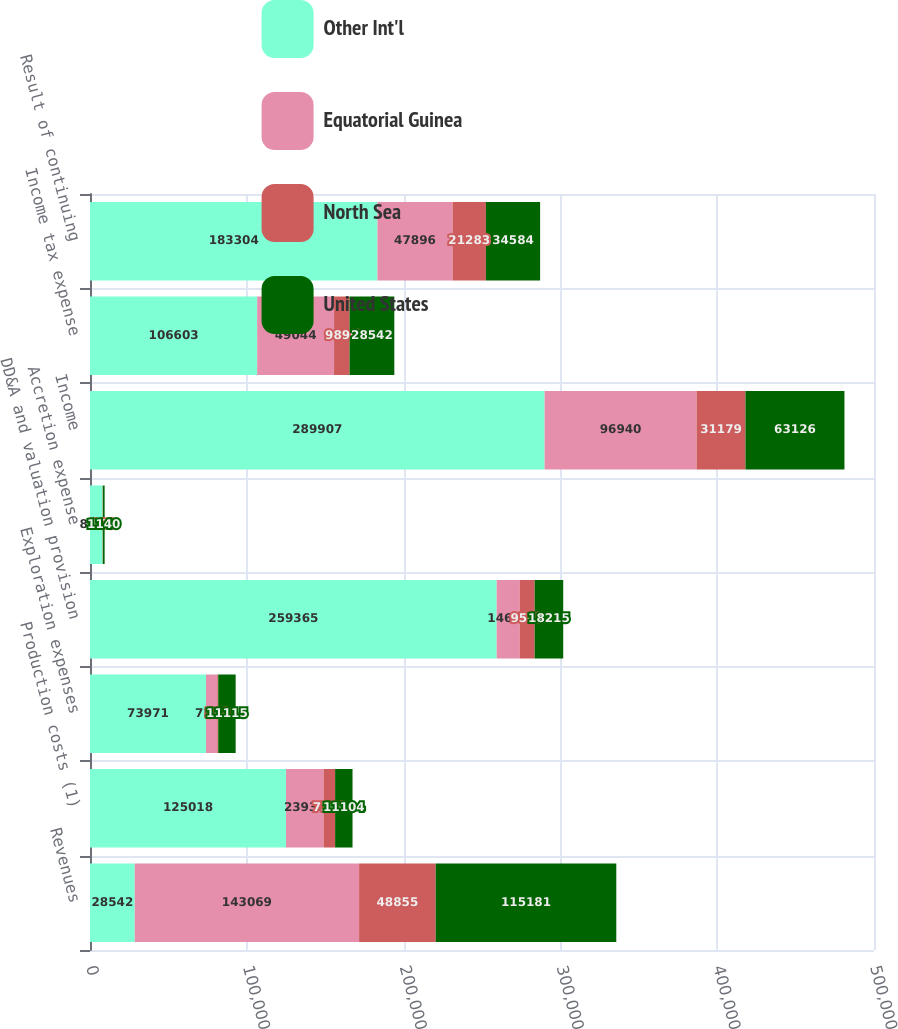Convert chart. <chart><loc_0><loc_0><loc_500><loc_500><stacked_bar_chart><ecel><fcel>Revenues<fcel>Production costs (1)<fcel>Exploration expenses<fcel>DD&A and valuation provision<fcel>Accretion expense<fcel>Income<fcel>Income tax expense<fcel>Result of continuing<nl><fcel>Other Int'l<fcel>28542<fcel>125018<fcel>73971<fcel>259365<fcel>8021<fcel>289907<fcel>106603<fcel>183304<nl><fcel>Equatorial Guinea<fcel>143069<fcel>23936<fcel>7214<fcel>14674<fcel>6<fcel>96940<fcel>49044<fcel>47896<nl><fcel>North Sea<fcel>48855<fcel>7366<fcel>598<fcel>9549<fcel>163<fcel>31179<fcel>9896<fcel>21283<nl><fcel>United States<fcel>115181<fcel>11104<fcel>11115<fcel>18215<fcel>1140<fcel>63126<fcel>28542<fcel>34584<nl></chart> 